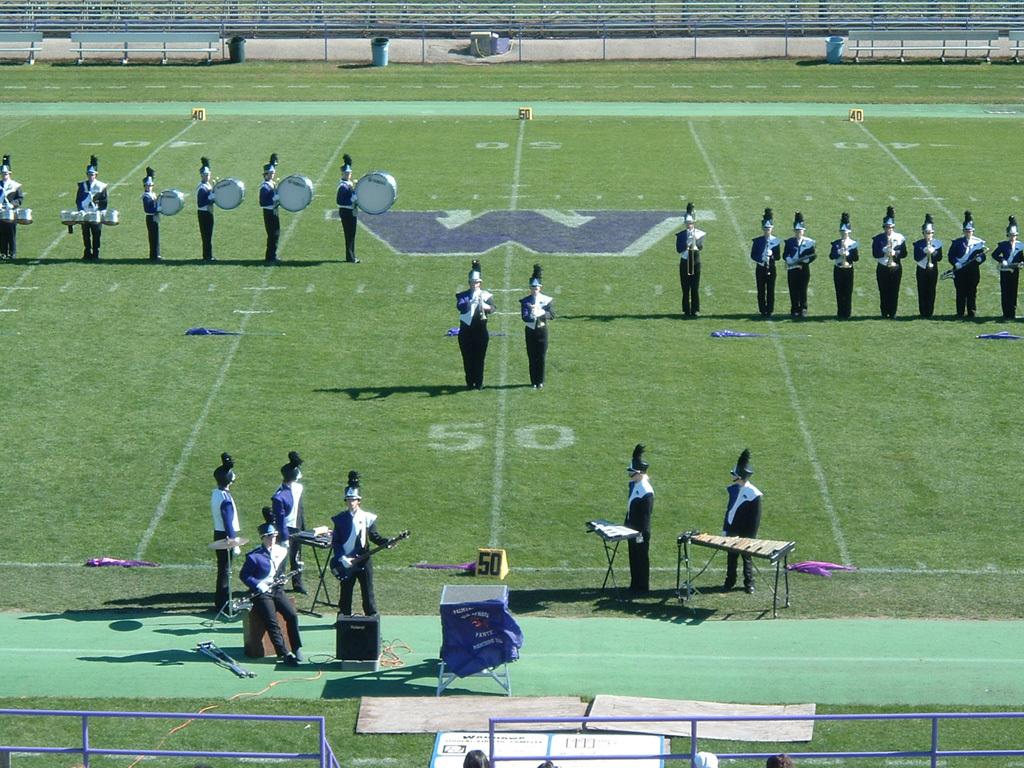What yardline are they centered on?
Provide a succinct answer. 50. What letter is spray painted on the middle of the field?
Offer a very short reply. W. 